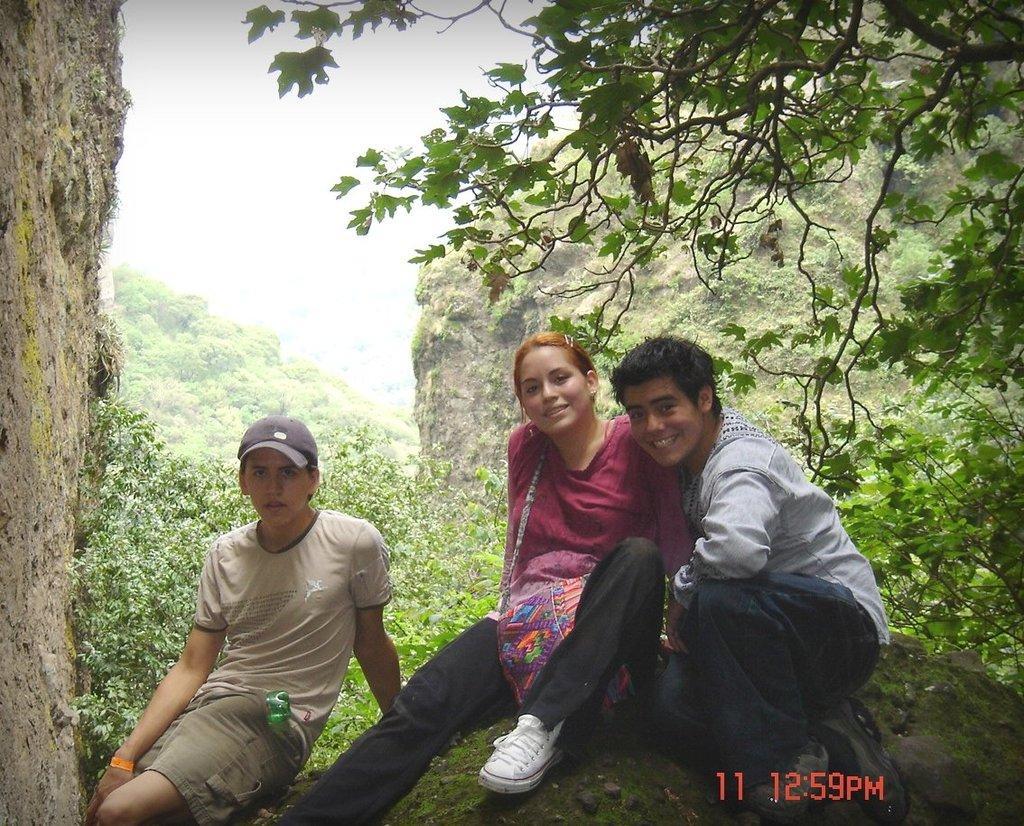Can you describe this image briefly? In this image I can see three people with different color dress and one person wearing the cap. In the background there are trees and the sky. 